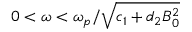Convert formula to latex. <formula><loc_0><loc_0><loc_500><loc_500>0 < \omega < \omega _ { p } / \sqrt { c _ { 1 } + d _ { 2 } B _ { 0 } ^ { 2 } }</formula> 